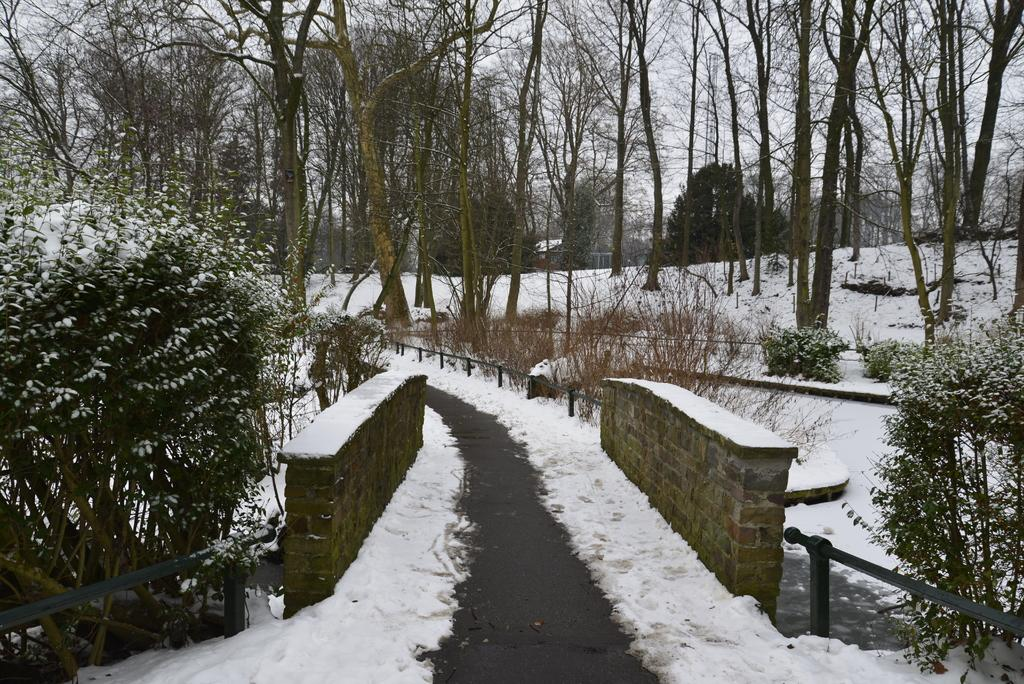What type of structure can be seen in the image? There is a small bridge with walls in the image. What is the pathway made of in the image? The facts do not specify the material of the pathway. What type of vegetation is present in the image? Trees and bushes are visible in the image. What is the weather like in the image? There is snow in the image, indicating a cold or wintery environment. How many pies are being served on the ground in the image? There are no pies present in the image; it features a pathway, a small bridge, trees, bushes, and snow. What type of ring can be seen on the trees in the image? There is no ring visible on the trees in the image. 